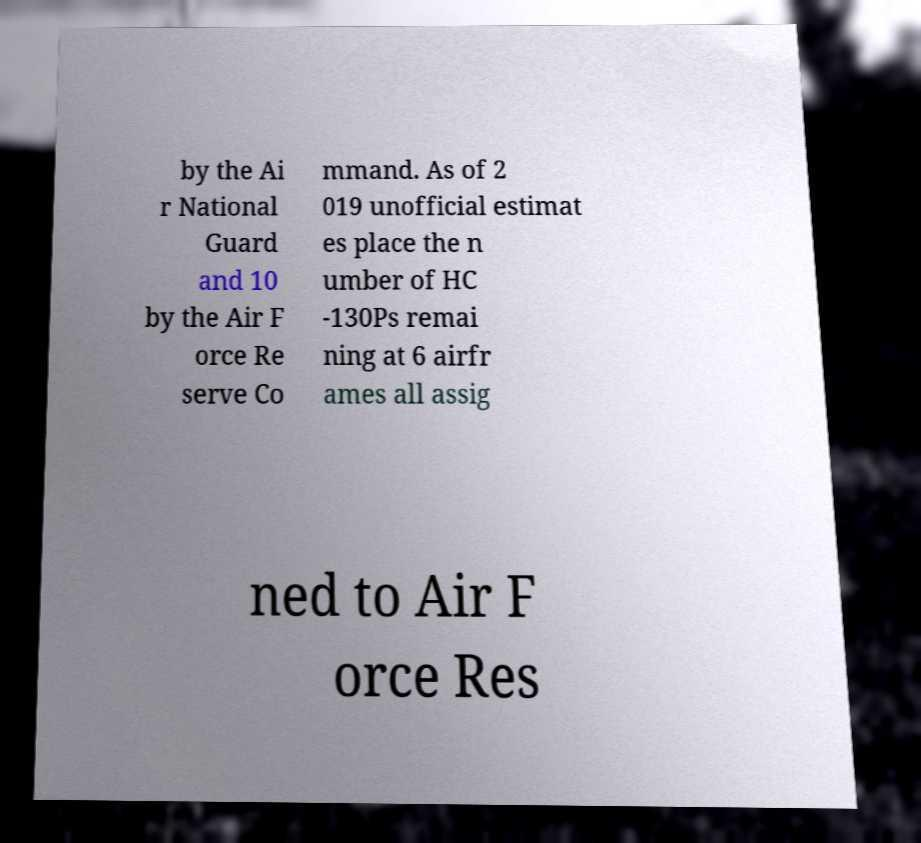There's text embedded in this image that I need extracted. Can you transcribe it verbatim? by the Ai r National Guard and 10 by the Air F orce Re serve Co mmand. As of 2 019 unofficial estimat es place the n umber of HC -130Ps remai ning at 6 airfr ames all assig ned to Air F orce Res 